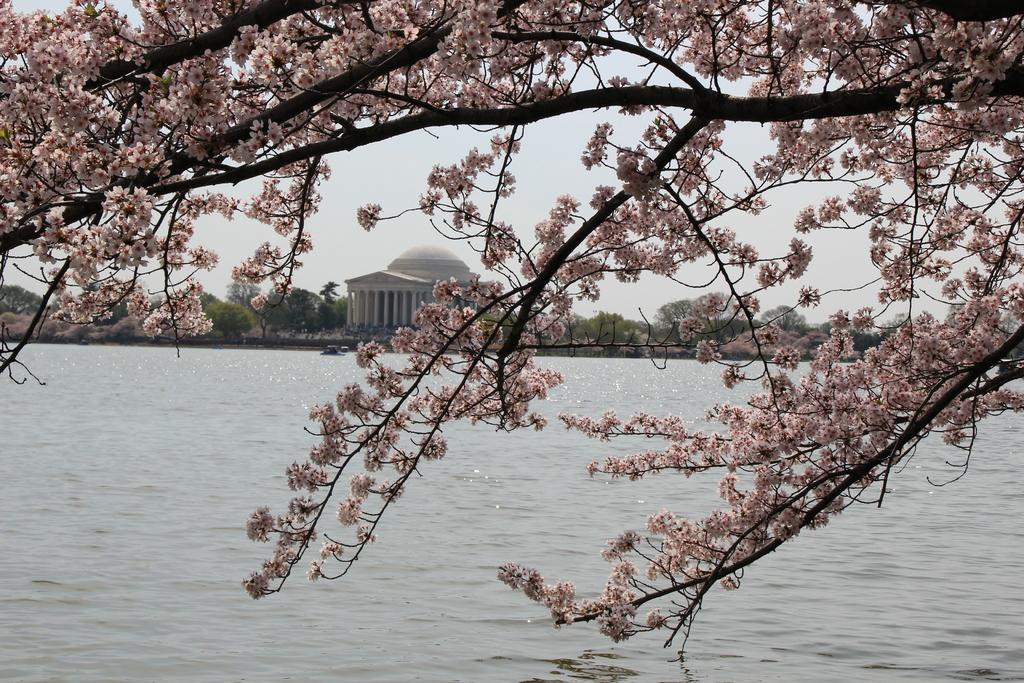What type of vegetation can be seen in the image? There are branches and flowers in the image. What natural element is visible in the image? There is water visible in the image. What type of plant life is present in the image? There are trees in the image. What man-made structure is visible in the image? There is a building in the image. What can be seen in the background of the image? The sky is visible in the background of the image. How many bikes are parked near the building in the image? There are no bikes present in the image. What type of experience can be gained from the flowers in the image? The image does not convey any specific experience related to the flowers; it simply shows their presence. 